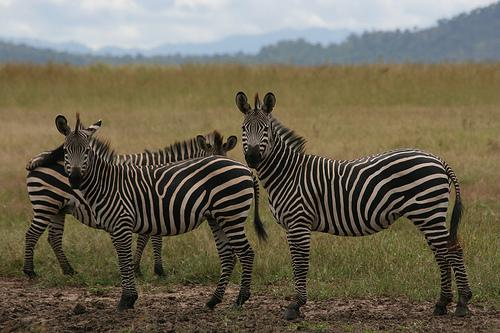Question: how is the weather?
Choices:
A. Cold.
B. Rainy.
C. Hot.
D. It is cloudy.
Answer with the letter. Answer: D Question: how many zebras are there?
Choices:
A. Two.
B. Four.
C. Three.
D. Five.
Answer with the letter. Answer: C Question: what are the zebras standing on?
Choices:
A. Grass.
B. Rocks.
C. Leafs.
D. Dirt.
Answer with the letter. Answer: D Question: what is in the background?
Choices:
A. Pond.
B. Grassland.
C. Volleyball net.
D. Basketball court.
Answer with the letter. Answer: B Question: what runs down the center of the zebra's head to its back?
Choices:
A. Mane.
B. Spine.
C. Hair.
D. Hair that sticks up.
Answer with the letter. Answer: D 